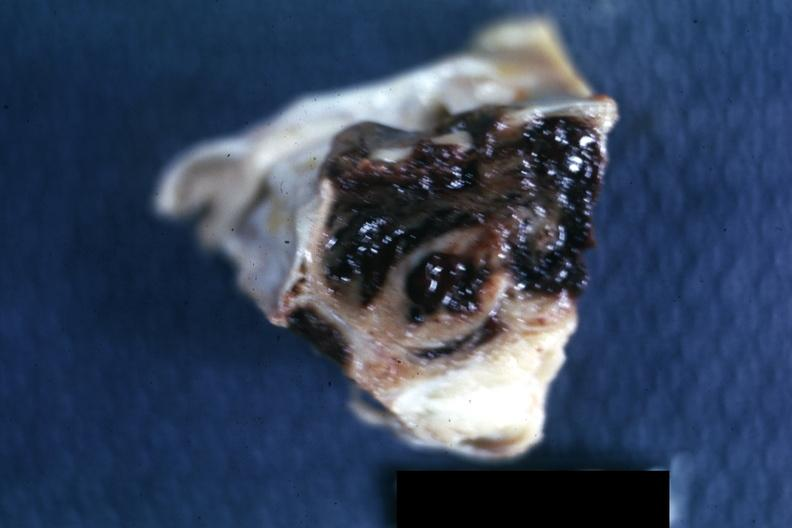what is present?
Answer the question using a single word or phrase. Endocrine 